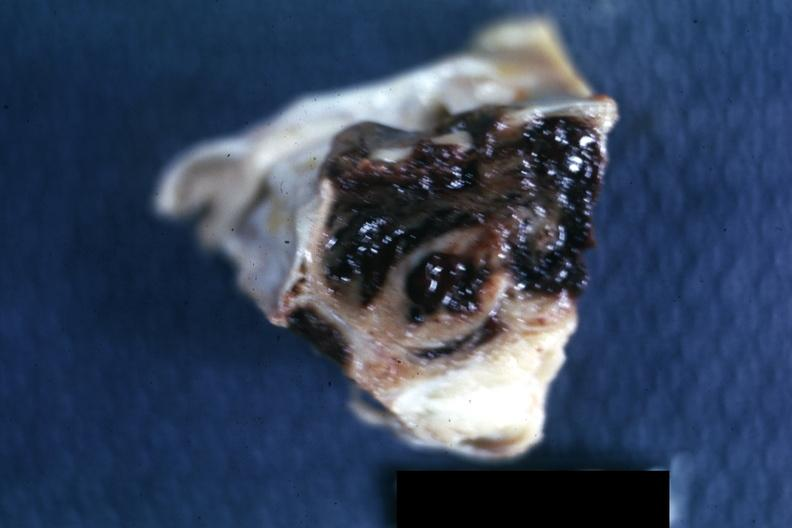what is present?
Answer the question using a single word or phrase. Endocrine 